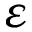Convert formula to latex. <formula><loc_0><loc_0><loc_500><loc_500>\varepsilon</formula> 